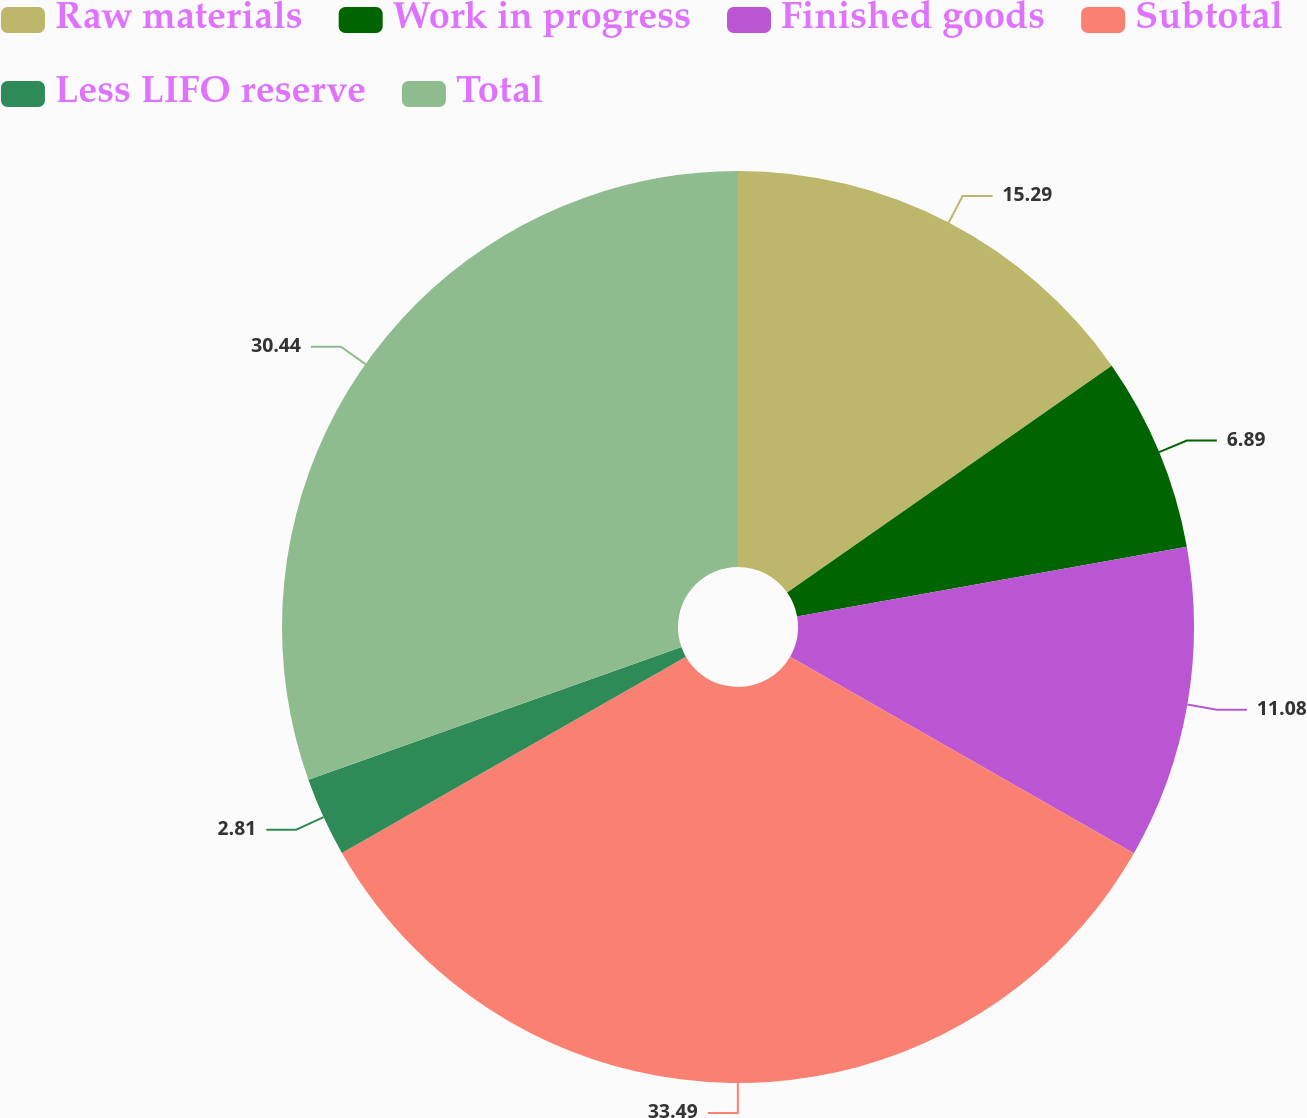<chart> <loc_0><loc_0><loc_500><loc_500><pie_chart><fcel>Raw materials<fcel>Work in progress<fcel>Finished goods<fcel>Subtotal<fcel>Less LIFO reserve<fcel>Total<nl><fcel>15.29%<fcel>6.89%<fcel>11.08%<fcel>33.49%<fcel>2.81%<fcel>30.44%<nl></chart> 